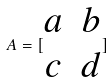Convert formula to latex. <formula><loc_0><loc_0><loc_500><loc_500>A = [ \begin{matrix} a & b \\ c & d \end{matrix} ]</formula> 